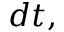<formula> <loc_0><loc_0><loc_500><loc_500>d t ,</formula> 